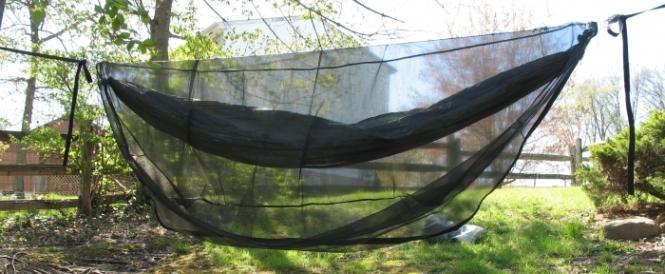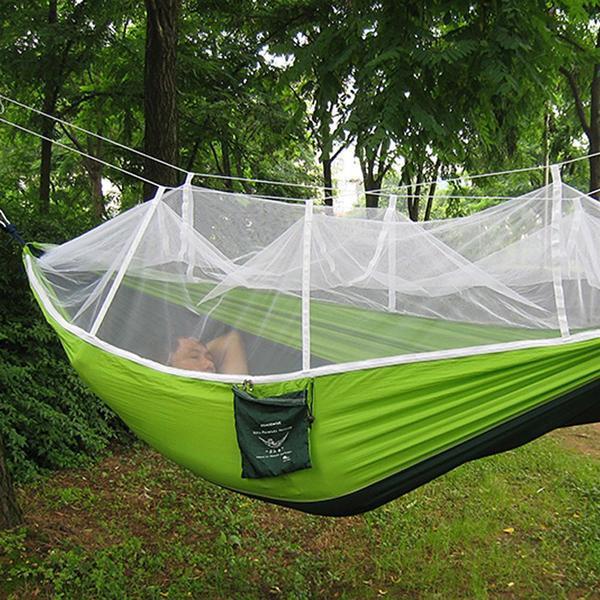The first image is the image on the left, the second image is the image on the right. Assess this claim about the two images: "An image shows a hanging hammock that does not contain a person.". Correct or not? Answer yes or no. Yes. The first image is the image on the left, the second image is the image on the right. For the images shown, is this caption "A blue hammock hangs from a tree in one of the images." true? Answer yes or no. No. 